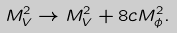<formula> <loc_0><loc_0><loc_500><loc_500>M _ { V } ^ { 2 } \rightarrow M _ { V } ^ { 2 } + 8 c M _ { \phi } ^ { 2 } .</formula> 